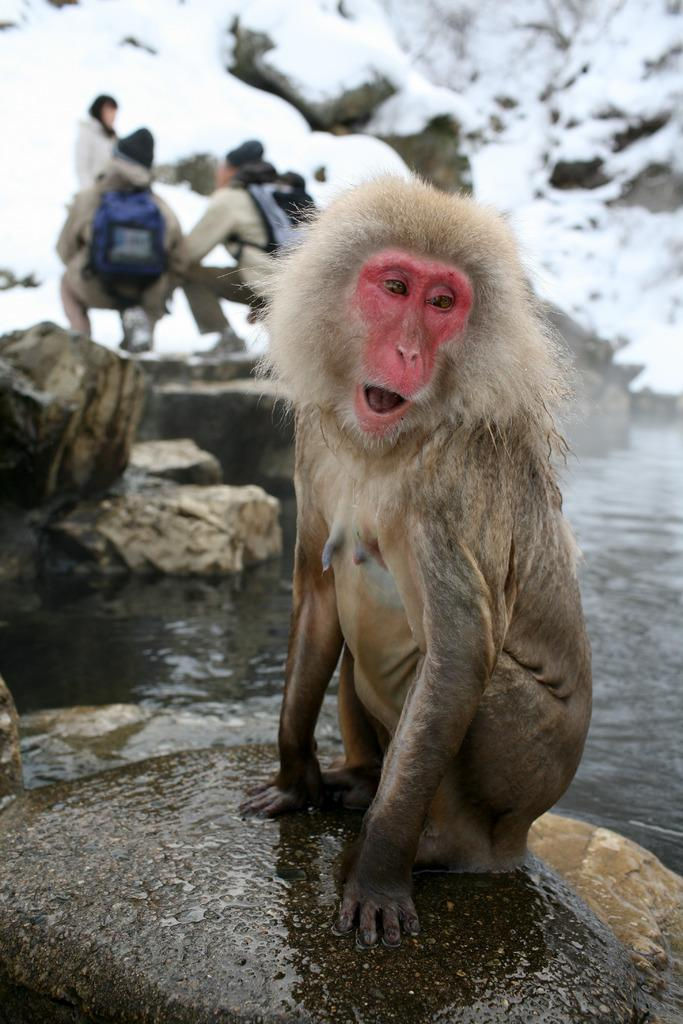What animal is sitting on the rock in the image? There is a monkey sitting on a rock in the image. What is the condition of the rock? The rock is wet. Can you describe the people in the background? There are persons in the background on the rock. What can be seen in the distance behind the rock? There is water visible in the background, and a mountain with snow on it. What type of oven can be seen in the image? There is no oven present in the image. How many days of the week are visible in the image? The concept of days of the week is not applicable to the image, as it is a visual representation of a scene and not a calendar or schedule. 